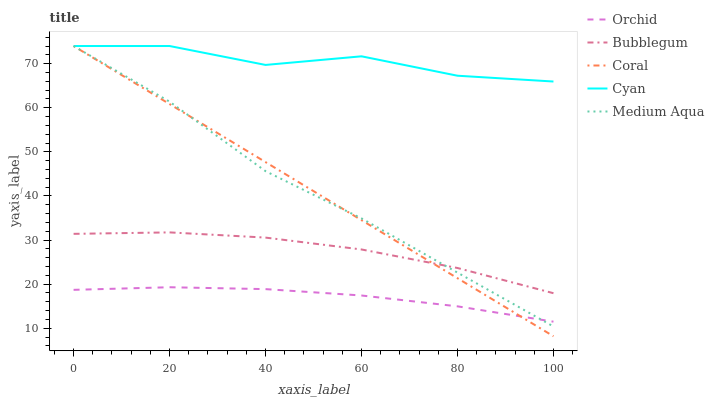Does Orchid have the minimum area under the curve?
Answer yes or no. Yes. Does Cyan have the maximum area under the curve?
Answer yes or no. Yes. Does Coral have the minimum area under the curve?
Answer yes or no. No. Does Coral have the maximum area under the curve?
Answer yes or no. No. Is Coral the smoothest?
Answer yes or no. Yes. Is Cyan the roughest?
Answer yes or no. Yes. Is Medium Aqua the smoothest?
Answer yes or no. No. Is Medium Aqua the roughest?
Answer yes or no. No. Does Coral have the lowest value?
Answer yes or no. Yes. Does Medium Aqua have the lowest value?
Answer yes or no. No. Does Medium Aqua have the highest value?
Answer yes or no. Yes. Does Bubblegum have the highest value?
Answer yes or no. No. Is Orchid less than Bubblegum?
Answer yes or no. Yes. Is Cyan greater than Orchid?
Answer yes or no. Yes. Does Orchid intersect Medium Aqua?
Answer yes or no. Yes. Is Orchid less than Medium Aqua?
Answer yes or no. No. Is Orchid greater than Medium Aqua?
Answer yes or no. No. Does Orchid intersect Bubblegum?
Answer yes or no. No. 